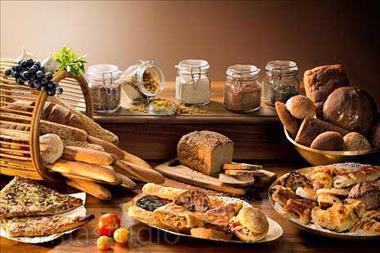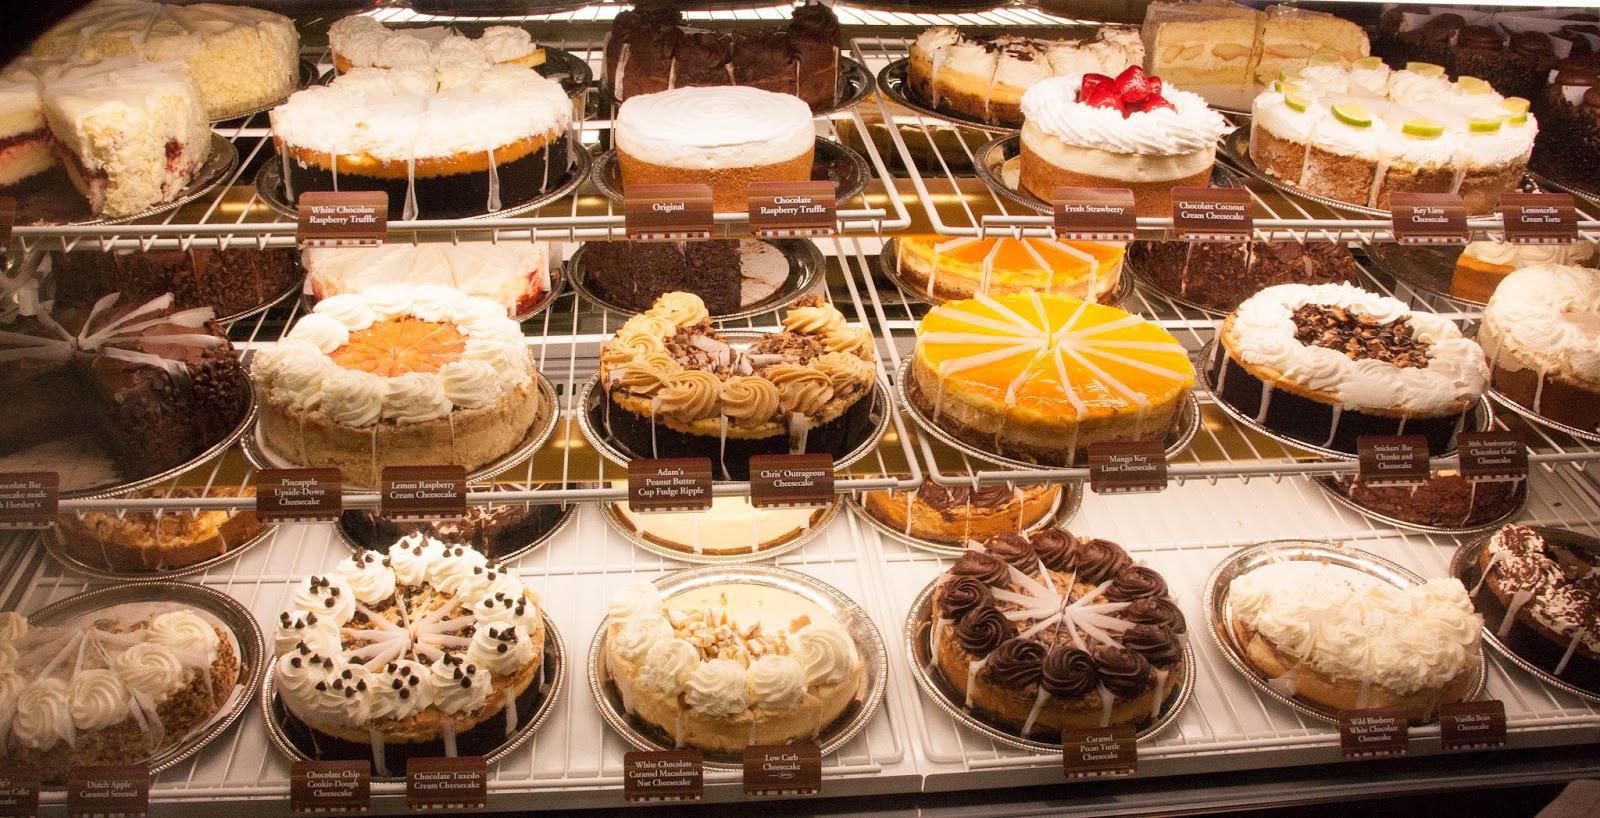The first image is the image on the left, the second image is the image on the right. For the images displayed, is the sentence "Some items are wrapped in clear plastic." factually correct? Answer yes or no. No. The first image is the image on the left, the second image is the image on the right. Evaluate the accuracy of this statement regarding the images: "The left image shows decorated cakes on at least the top row of a glass case, and the decorations include upright chocolate shapes.". Is it true? Answer yes or no. No. 